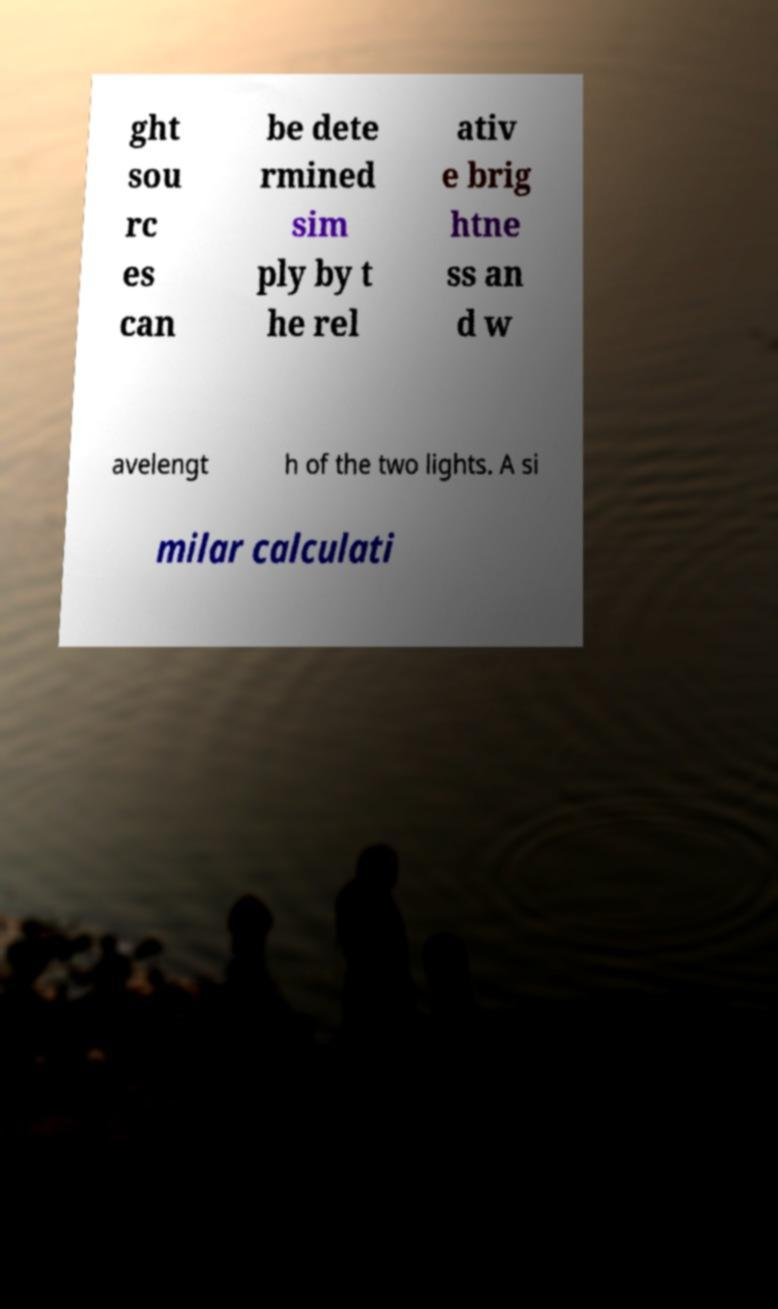Please read and relay the text visible in this image. What does it say? ght sou rc es can be dete rmined sim ply by t he rel ativ e brig htne ss an d w avelengt h of the two lights. A si milar calculati 